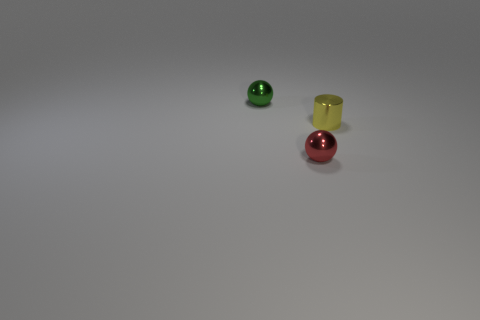How many objects are there in the image, and can you describe them? There are three objects in the image: a green ball with a reflective surface, a red ball also with a reflective surface, and a translucent yellow cup with a matte finish. What could be the context or setting where these objects are placed? The objects could be part of a simple color and material study, demonstrating how different textures and colors interact with light. Alternatively, they could be part of a child's play area, given the playful nature of the items. 